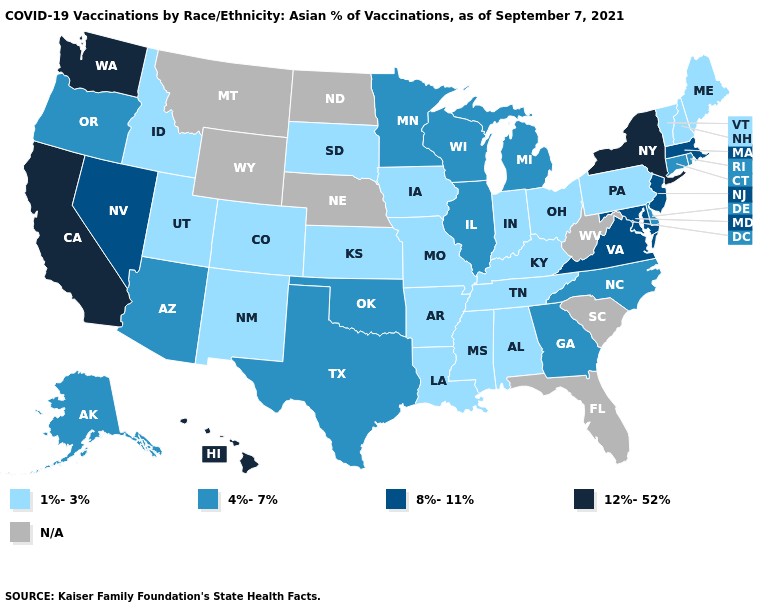Among the states that border New Hampshire , does Massachusetts have the highest value?
Short answer required. Yes. Among the states that border Kansas , which have the lowest value?
Concise answer only. Colorado, Missouri. What is the highest value in the USA?
Quick response, please. 12%-52%. Among the states that border Georgia , does North Carolina have the lowest value?
Answer briefly. No. Which states have the highest value in the USA?
Be succinct. California, Hawaii, New York, Washington. What is the value of Florida?
Quick response, please. N/A. Among the states that border Wyoming , which have the lowest value?
Be succinct. Colorado, Idaho, South Dakota, Utah. What is the highest value in the Northeast ?
Quick response, please. 12%-52%. Does Hawaii have the highest value in the USA?
Give a very brief answer. Yes. Does California have the highest value in the USA?
Answer briefly. Yes. Which states have the highest value in the USA?
Give a very brief answer. California, Hawaii, New York, Washington. What is the value of New Jersey?
Quick response, please. 8%-11%. Name the states that have a value in the range 8%-11%?
Write a very short answer. Maryland, Massachusetts, Nevada, New Jersey, Virginia. What is the value of Montana?
Be succinct. N/A. What is the value of Kansas?
Short answer required. 1%-3%. 